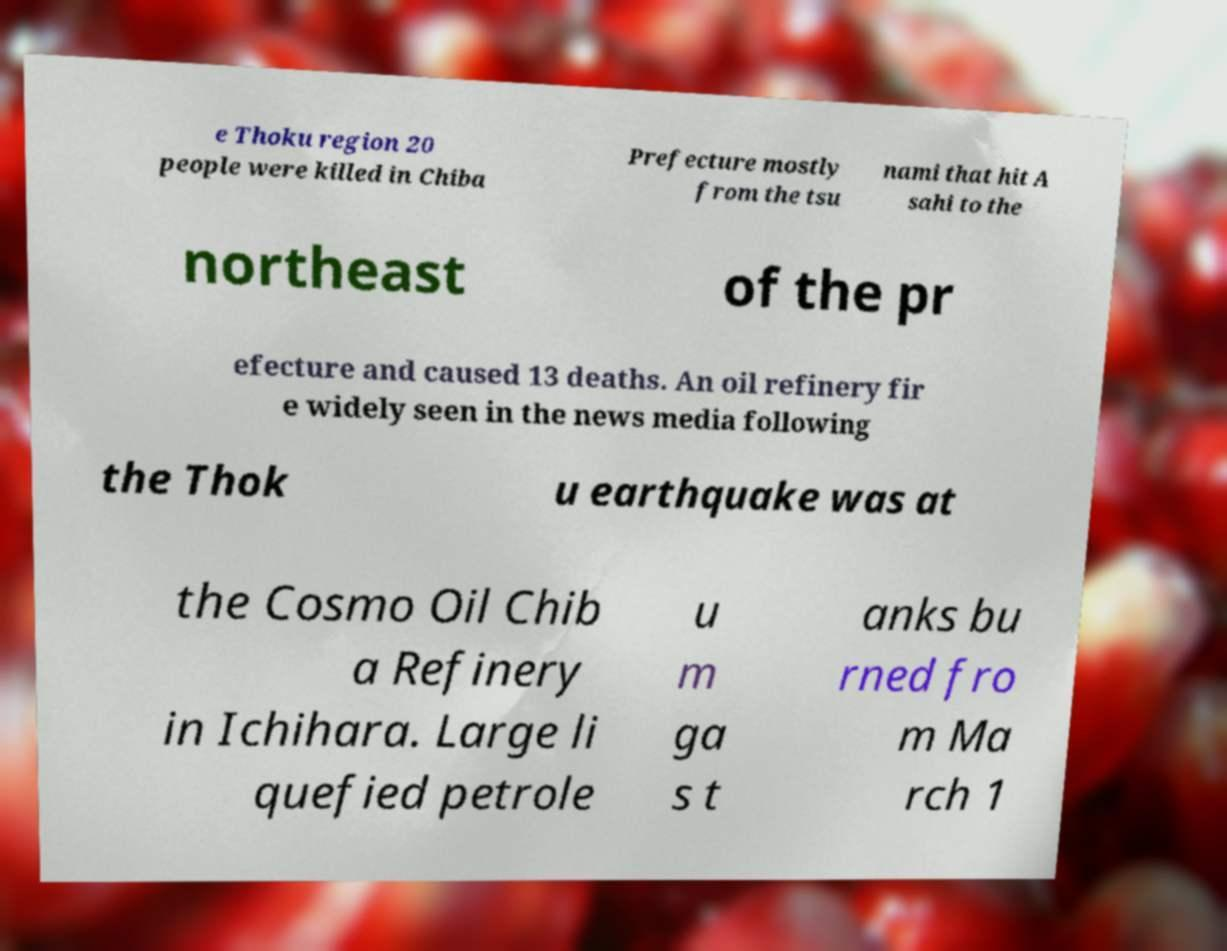Please read and relay the text visible in this image. What does it say? e Thoku region 20 people were killed in Chiba Prefecture mostly from the tsu nami that hit A sahi to the northeast of the pr efecture and caused 13 deaths. An oil refinery fir e widely seen in the news media following the Thok u earthquake was at the Cosmo Oil Chib a Refinery in Ichihara. Large li quefied petrole u m ga s t anks bu rned fro m Ma rch 1 